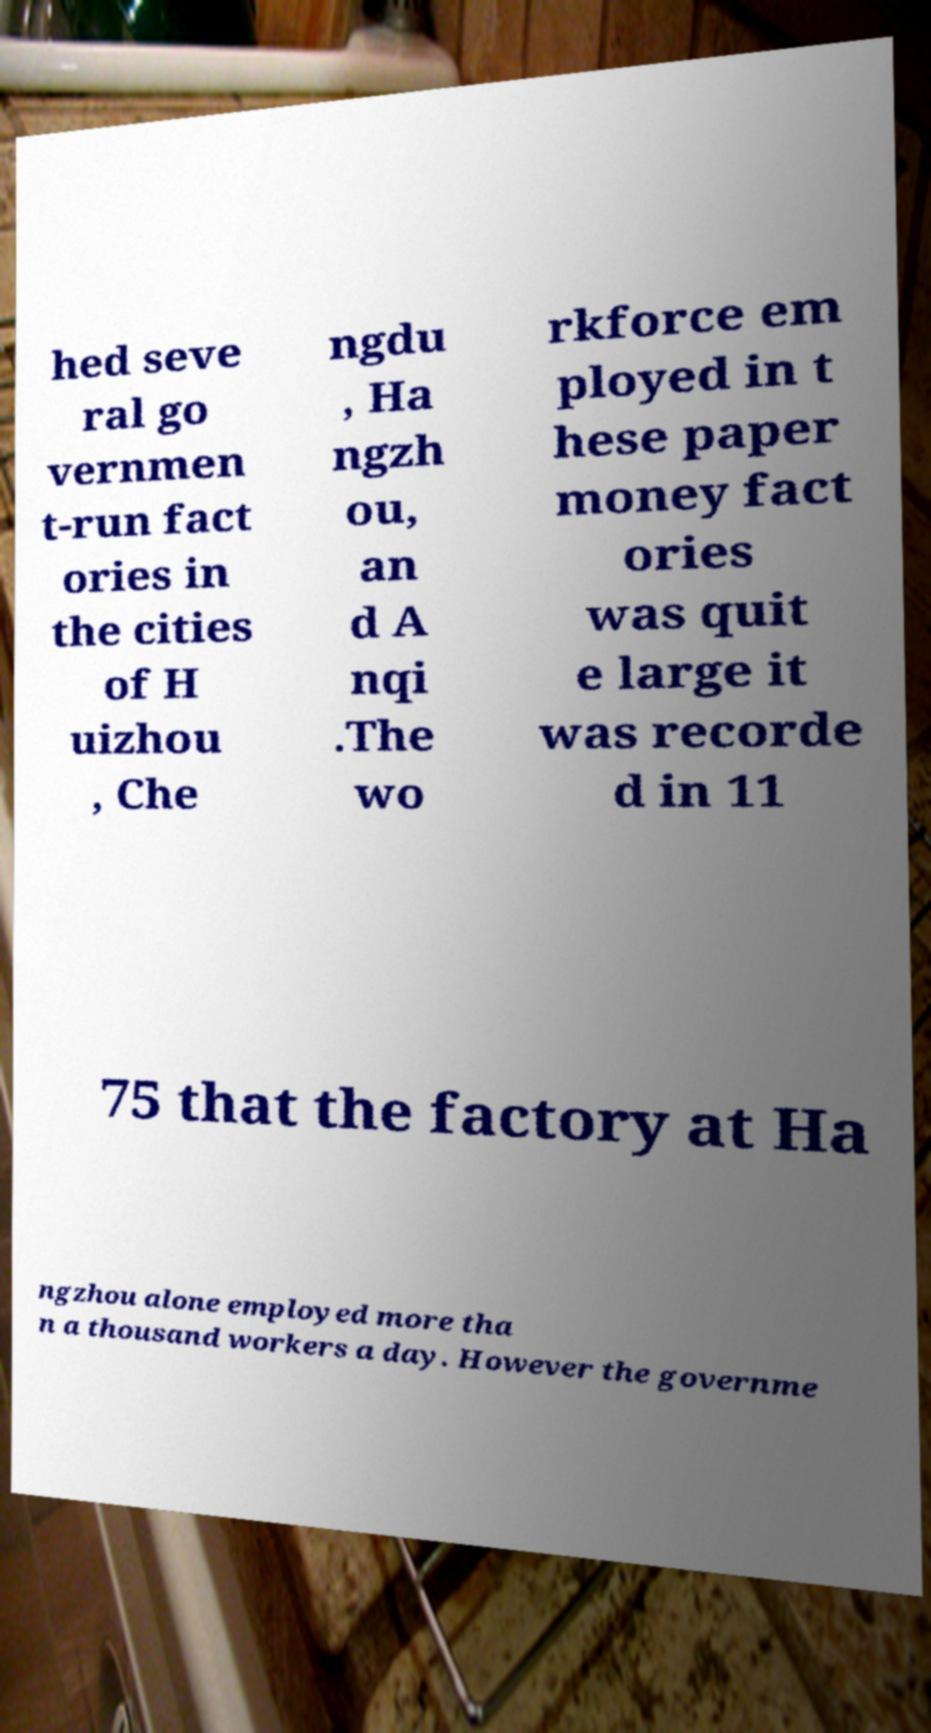For documentation purposes, I need the text within this image transcribed. Could you provide that? hed seve ral go vernmen t-run fact ories in the cities of H uizhou , Che ngdu , Ha ngzh ou, an d A nqi .The wo rkforce em ployed in t hese paper money fact ories was quit e large it was recorde d in 11 75 that the factory at Ha ngzhou alone employed more tha n a thousand workers a day. However the governme 